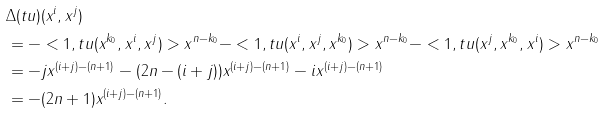Convert formula to latex. <formula><loc_0><loc_0><loc_500><loc_500>& \Delta ( t u ) ( x ^ { i } , x ^ { j } ) \\ & = - < 1 , t u ( x ^ { k _ { 0 } } , x ^ { i } , x ^ { j } ) > x ^ { n - k _ { 0 } } - < 1 , t u ( x ^ { i } , x ^ { j } , x ^ { k _ { 0 } } ) > x ^ { n - k _ { 0 } } - < 1 , t u ( x ^ { j } , x ^ { k _ { 0 } } , x ^ { i } ) > x ^ { n - k _ { 0 } } \\ & = - j x ^ { ( i + j ) - ( n + 1 ) } - ( 2 n - ( i + j ) ) x ^ { ( i + j ) - ( n + 1 ) } - i x ^ { ( i + j ) - ( n + 1 ) } \\ & = - ( 2 n + 1 ) x ^ { ( i + j ) - ( n + 1 ) } . \\</formula> 